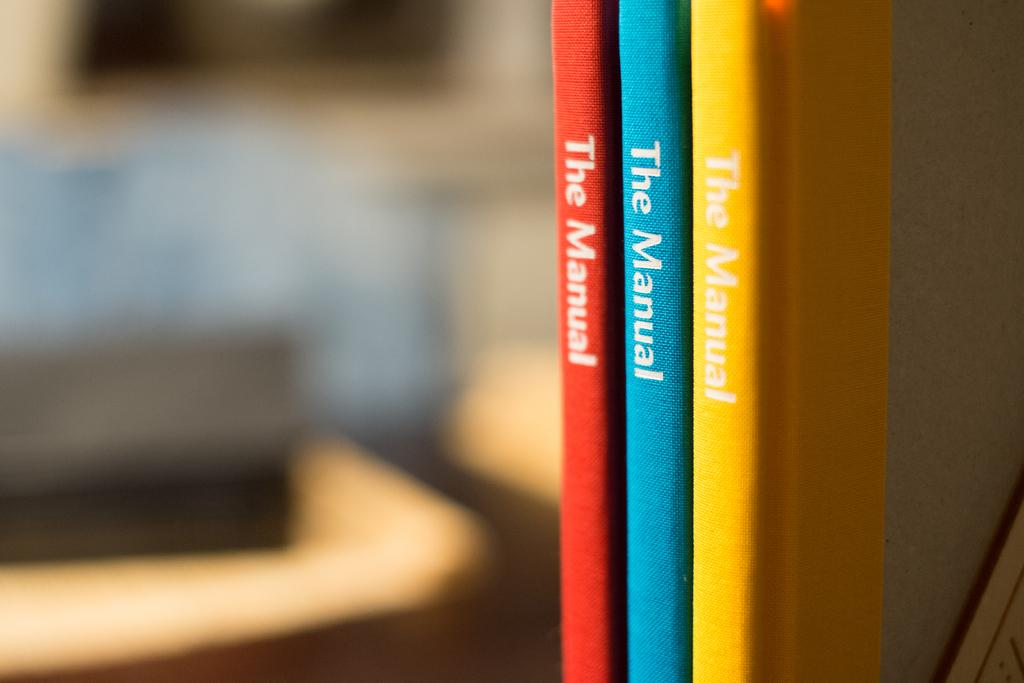<image>
Present a compact description of the photo's key features. Three different colored books each called The Manual. 